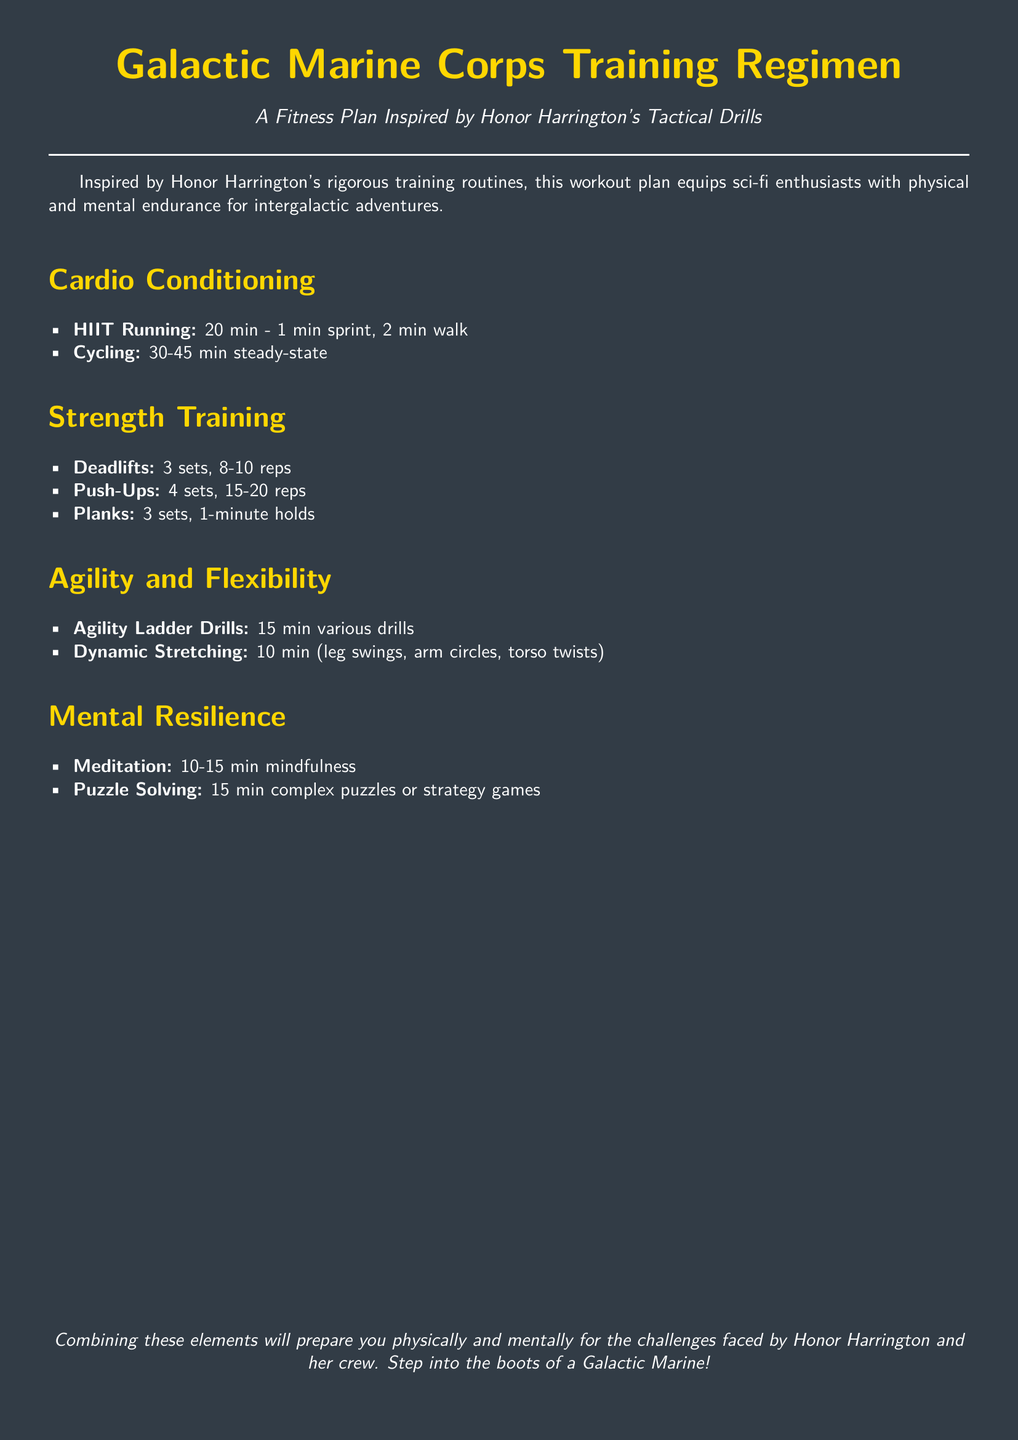What is the title of the workout plan? The title of the workout plan is prominently displayed at the top of the document.
Answer: Galactic Marine Corps Training Regimen How long is the HIIT Running session? The document specifies the duration for the HIIT Running exercise in the Cardio Conditioning section.
Answer: 20 min How many sets of Push-Ups are recommended? The number of sets for Push-Ups is listed under Strength Training.
Answer: 4 sets What type of mental exercise is suggested for Mental Resilience? The document includes activities aimed at improving mental resilience in the respective section.
Answer: Puzzle Solving What is the duration of the Meditation session? The document specifies the time range for Meditation in the Mental Resilience section.
Answer: 10-15 min How many minutes are dedicated to Agility Ladder Drills? The duration for Agility Ladder Drills is mentioned in the Agility and Flexibility section.
Answer: 15 min What is the minimum hold time for Planks? The minimum hold time for Planks is specified in the Strength Training section of the document.
Answer: 1-minute holds What is the purpose of this Fitness Plan? The introduction of the document states the purpose of the workout plan.
Answer: Equip sci-fi enthusiasts with physical and mental endurance 